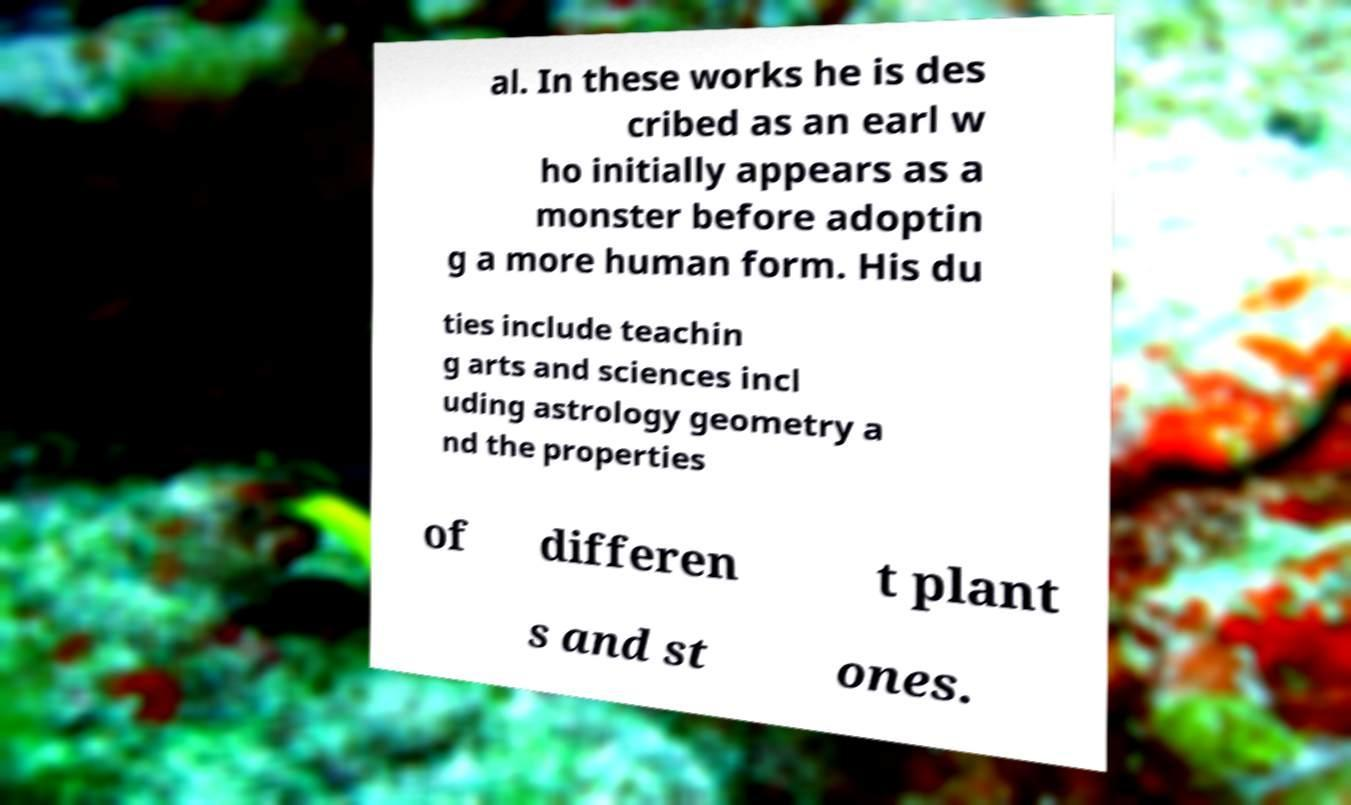Can you accurately transcribe the text from the provided image for me? al. In these works he is des cribed as an earl w ho initially appears as a monster before adoptin g a more human form. His du ties include teachin g arts and sciences incl uding astrology geometry a nd the properties of differen t plant s and st ones. 